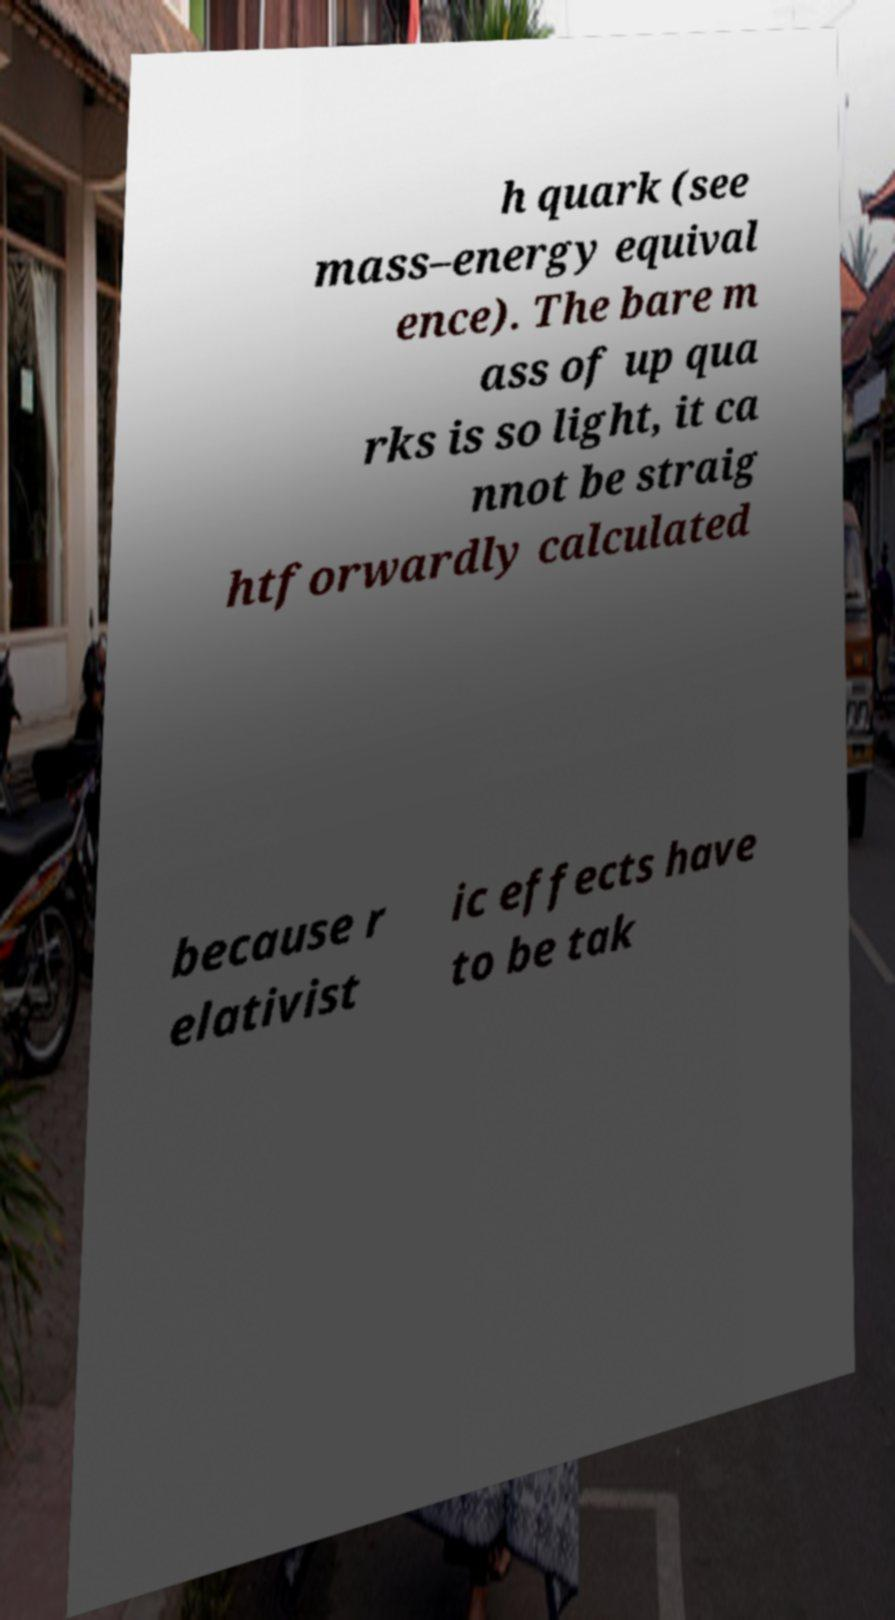I need the written content from this picture converted into text. Can you do that? h quark (see mass–energy equival ence). The bare m ass of up qua rks is so light, it ca nnot be straig htforwardly calculated because r elativist ic effects have to be tak 